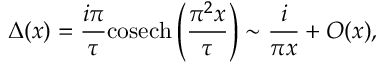<formula> <loc_0><loc_0><loc_500><loc_500>\Delta ( x ) = \frac { i \pi } { \tau } { \cos e c h } \left ( \frac { \pi ^ { 2 } x } { \tau } \right ) \sim \frac { i } { \pi x } + O ( x ) ,</formula> 